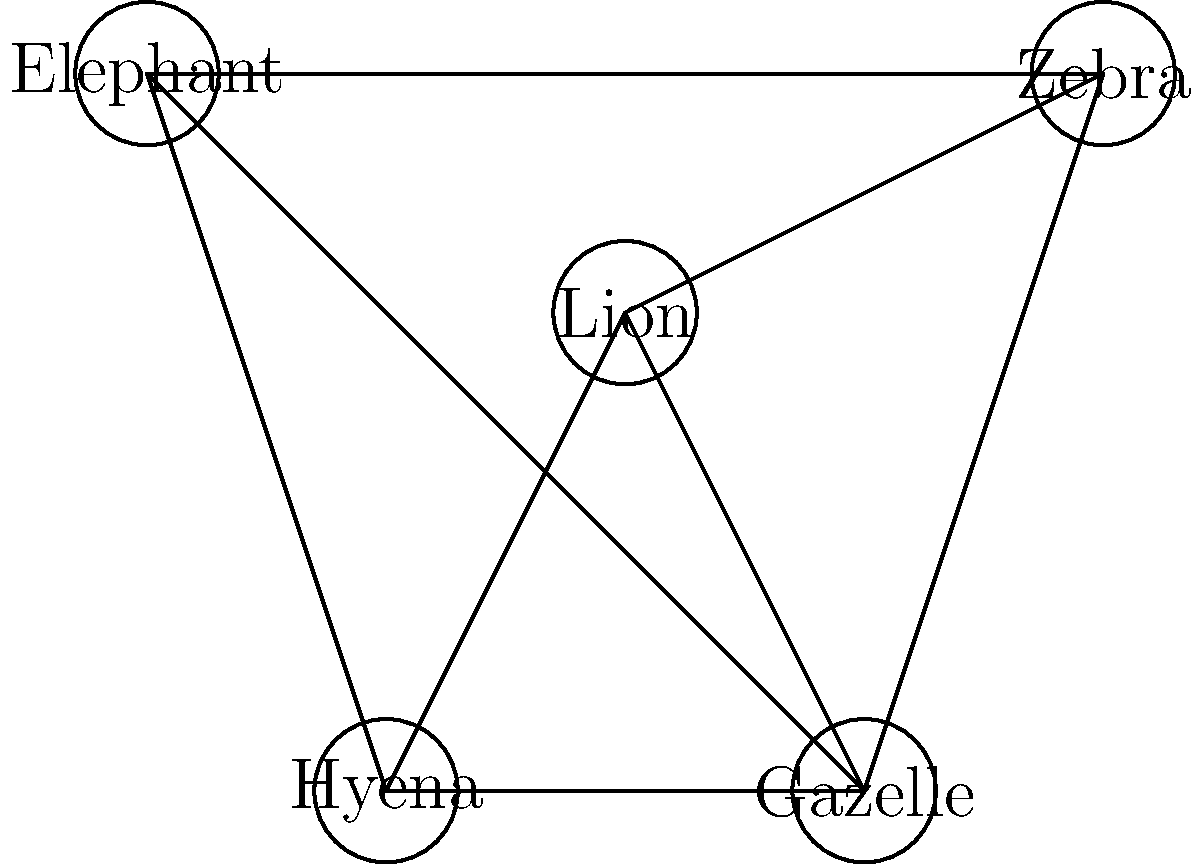In an African savanna ecosystem, different animal species interact with each other. The graph represents these interactions, where each node is a species and each edge indicates a significant ecological relationship (e.g., predator-prey, competition). How many colors are needed to color this graph so that no two adjacent nodes have the same color, representing the minimum number of distinct ecological roles in this ecosystem? To solve this graph coloring problem, we'll follow these steps:

1. Identify the number of nodes (species) in the graph:
   There are 5 nodes: Lion, Zebra, Gazelle, Hyena, and Elephant.

2. Analyze the connections between nodes:
   - Lion is connected to Zebra, Gazelle, and Hyena
   - Zebra is connected to Lion, Gazelle, and Elephant
   - Gazelle is connected to all other species
   - Hyena is connected to Lion, Gazelle, and Elephant
   - Elephant is connected to Zebra, Gazelle, and Hyena

3. Start coloring the graph:
   - Assign color 1 to Lion
   - Zebra, Gazelle, and Hyena can't be color 1, so assign color 2 to Zebra
   - Gazelle can't be color 1 or 2, so assign color 3 to Gazelle
   - Hyena can't be color 1 or 3, so it can be color 2
   - Elephant can't be color 2 or 3, so it can be color 1

4. Check if the coloring is valid:
   - No two adjacent nodes have the same color
   - We used 3 colors in total

5. Verify that this is the minimum number of colors:
   - We can't use fewer than 3 colors because Gazelle is connected to all other nodes

Therefore, the minimum number of colors needed to color this graph is 3, representing 3 distinct ecological roles in this ecosystem.
Answer: 3 colors 